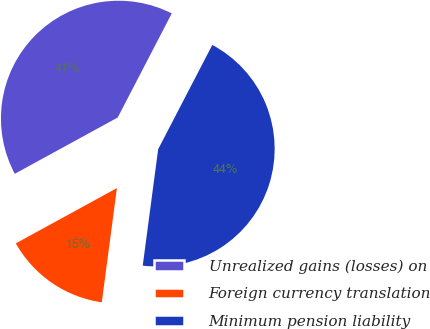Convert chart. <chart><loc_0><loc_0><loc_500><loc_500><pie_chart><fcel>Unrealized gains (losses) on<fcel>Foreign currency translation<fcel>Minimum pension liability<nl><fcel>40.59%<fcel>14.94%<fcel>44.48%<nl></chart> 